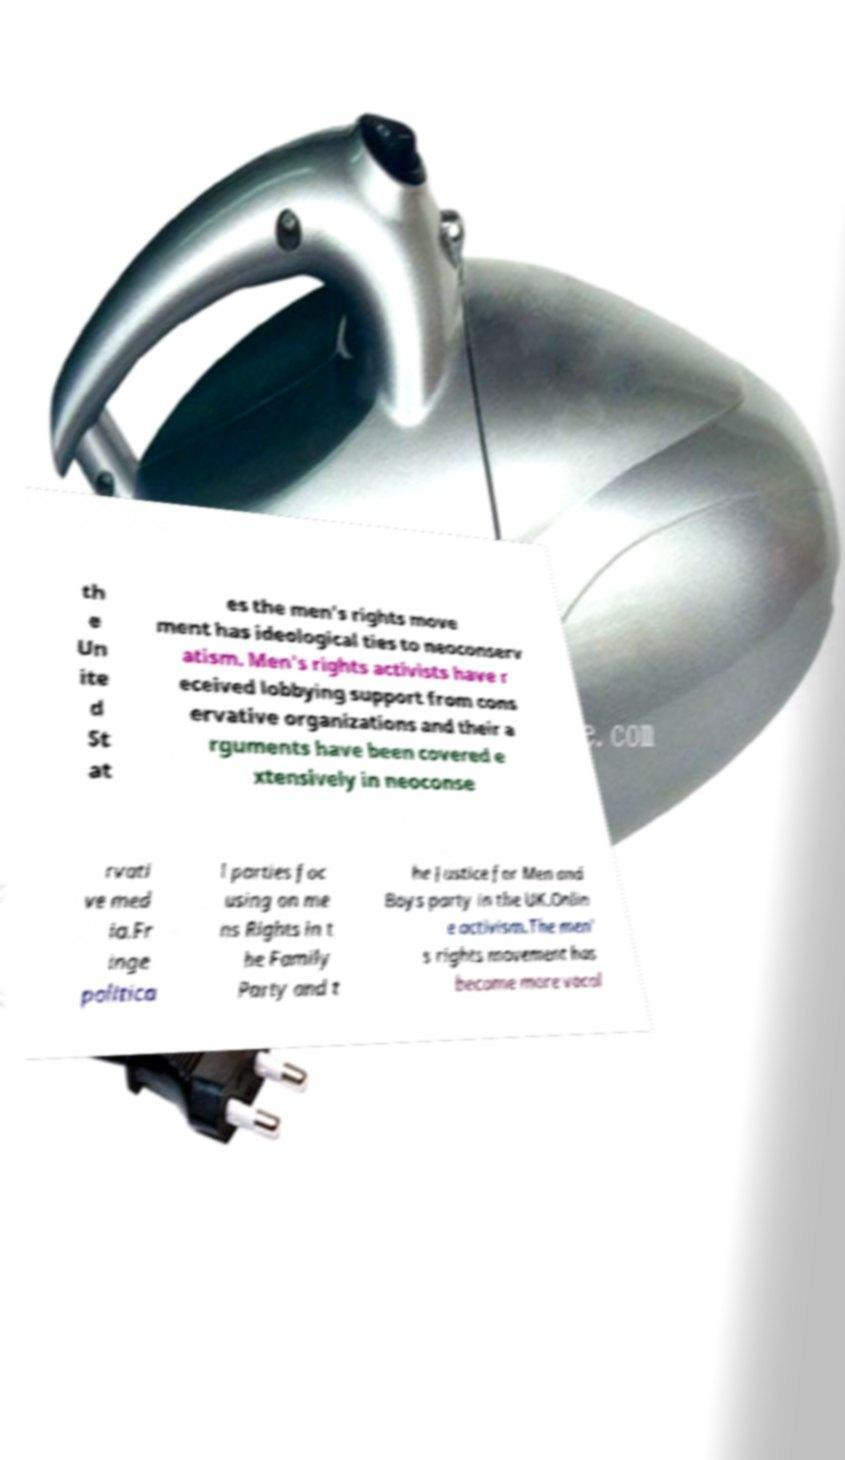I need the written content from this picture converted into text. Can you do that? th e Un ite d St at es the men's rights move ment has ideological ties to neoconserv atism. Men's rights activists have r eceived lobbying support from cons ervative organizations and their a rguments have been covered e xtensively in neoconse rvati ve med ia.Fr inge politica l parties foc using on me ns Rights in t he Family Party and t he Justice for Men and Boys party in the UK.Onlin e activism.The men' s rights movement has become more vocal 